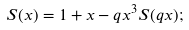<formula> <loc_0><loc_0><loc_500><loc_500>S ( x ) = 1 + x - q x ^ { 3 } S ( q x ) ;</formula> 